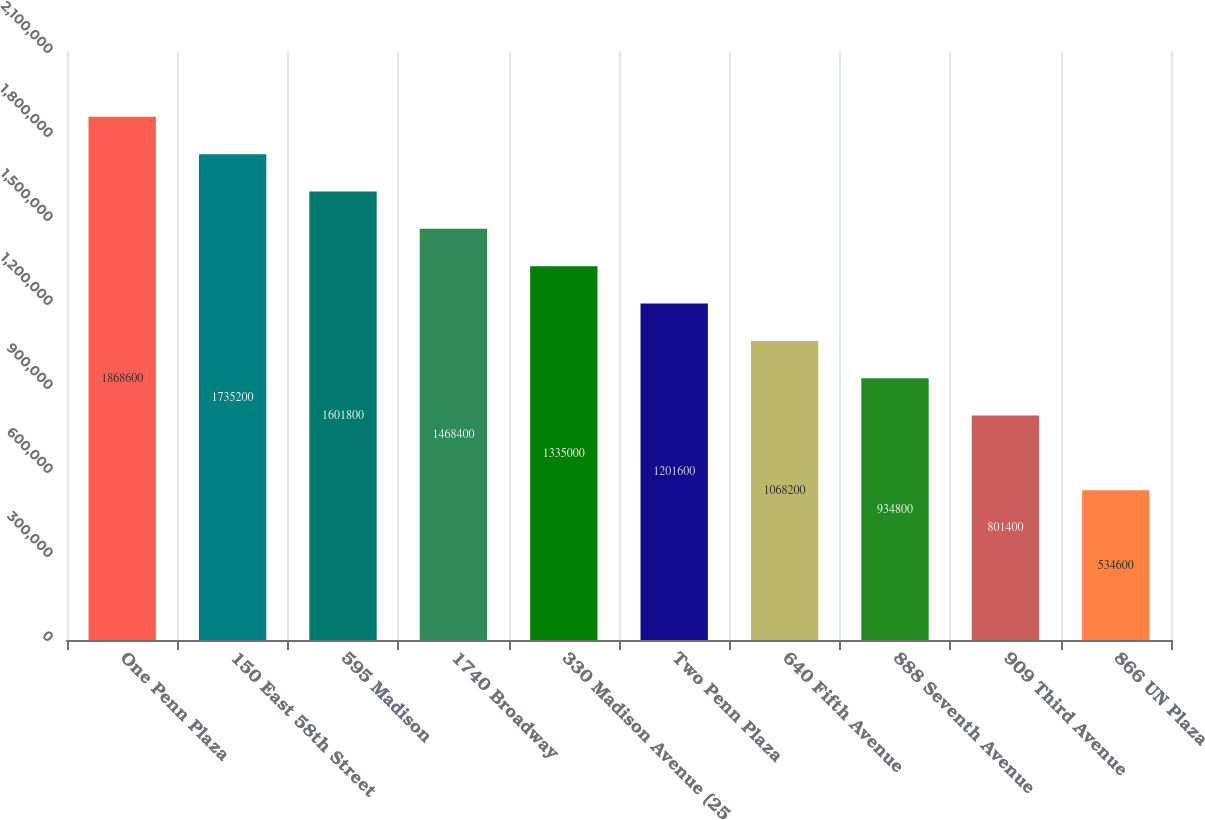Convert chart. <chart><loc_0><loc_0><loc_500><loc_500><bar_chart><fcel>One Penn Plaza<fcel>150 East 58th Street<fcel>595 Madison<fcel>1740 Broadway<fcel>330 Madison Avenue (25<fcel>Two Penn Plaza<fcel>640 Fifth Avenue<fcel>888 Seventh Avenue<fcel>909 Third Avenue<fcel>866 UN Plaza<nl><fcel>1.8686e+06<fcel>1.7352e+06<fcel>1.6018e+06<fcel>1.4684e+06<fcel>1.335e+06<fcel>1.2016e+06<fcel>1.0682e+06<fcel>934800<fcel>801400<fcel>534600<nl></chart> 